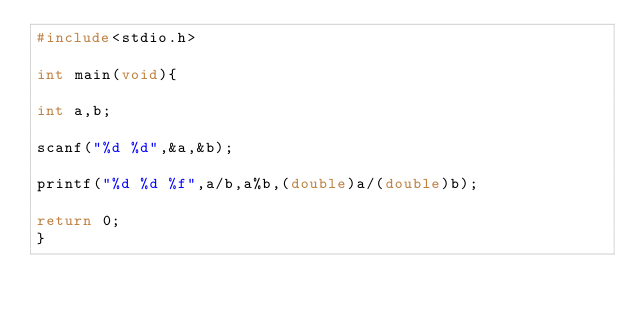<code> <loc_0><loc_0><loc_500><loc_500><_C_>#include<stdio.h>

int main(void){

int a,b;

scanf("%d %d",&a,&b);

printf("%d %d %f",a/b,a%b,(double)a/(double)b);

return 0;
}
</code> 